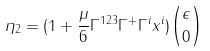Convert formula to latex. <formula><loc_0><loc_0><loc_500><loc_500>\eta _ { 2 } = ( 1 + \frac { \mu } { 6 } \Gamma ^ { 1 2 3 } \Gamma ^ { + } \Gamma ^ { i } x ^ { i } ) { \epsilon \choose 0 }</formula> 